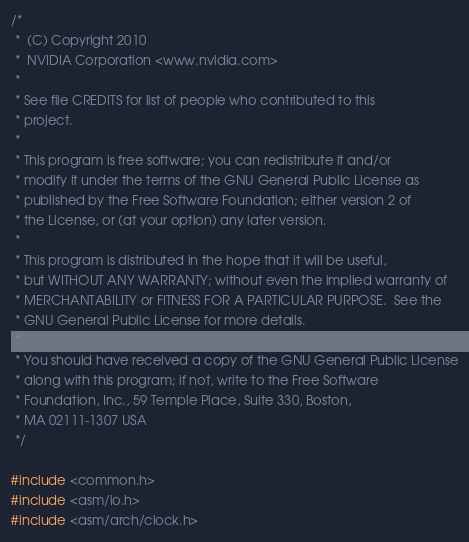<code> <loc_0><loc_0><loc_500><loc_500><_C_>/*
 *  (C) Copyright 2010
 *  NVIDIA Corporation <www.nvidia.com>
 *
 * See file CREDITS for list of people who contributed to this
 * project.
 *
 * This program is free software; you can redistribute it and/or
 * modify it under the terms of the GNU General Public License as
 * published by the Free Software Foundation; either version 2 of
 * the License, or (at your option) any later version.
 *
 * This program is distributed in the hope that it will be useful,
 * but WITHOUT ANY WARRANTY; without even the implied warranty of
 * MERCHANTABILITY or FITNESS FOR A PARTICULAR PURPOSE.  See the
 * GNU General Public License for more details.
 *
 * You should have received a copy of the GNU General Public License
 * along with this program; if not, write to the Free Software
 * Foundation, Inc., 59 Temple Place, Suite 330, Boston,
 * MA 02111-1307 USA
 */

#include <common.h>
#include <asm/io.h>
#include <asm/arch/clock.h></code> 